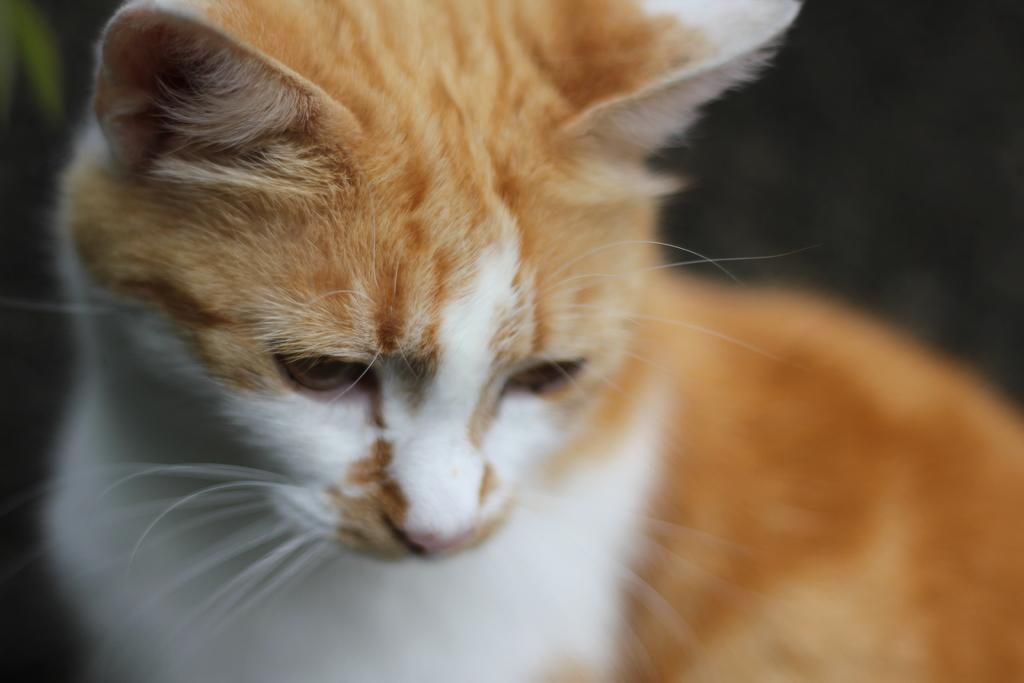How would you summarize this image in a sentence or two? Here in this picture we can see a cat present over there. 